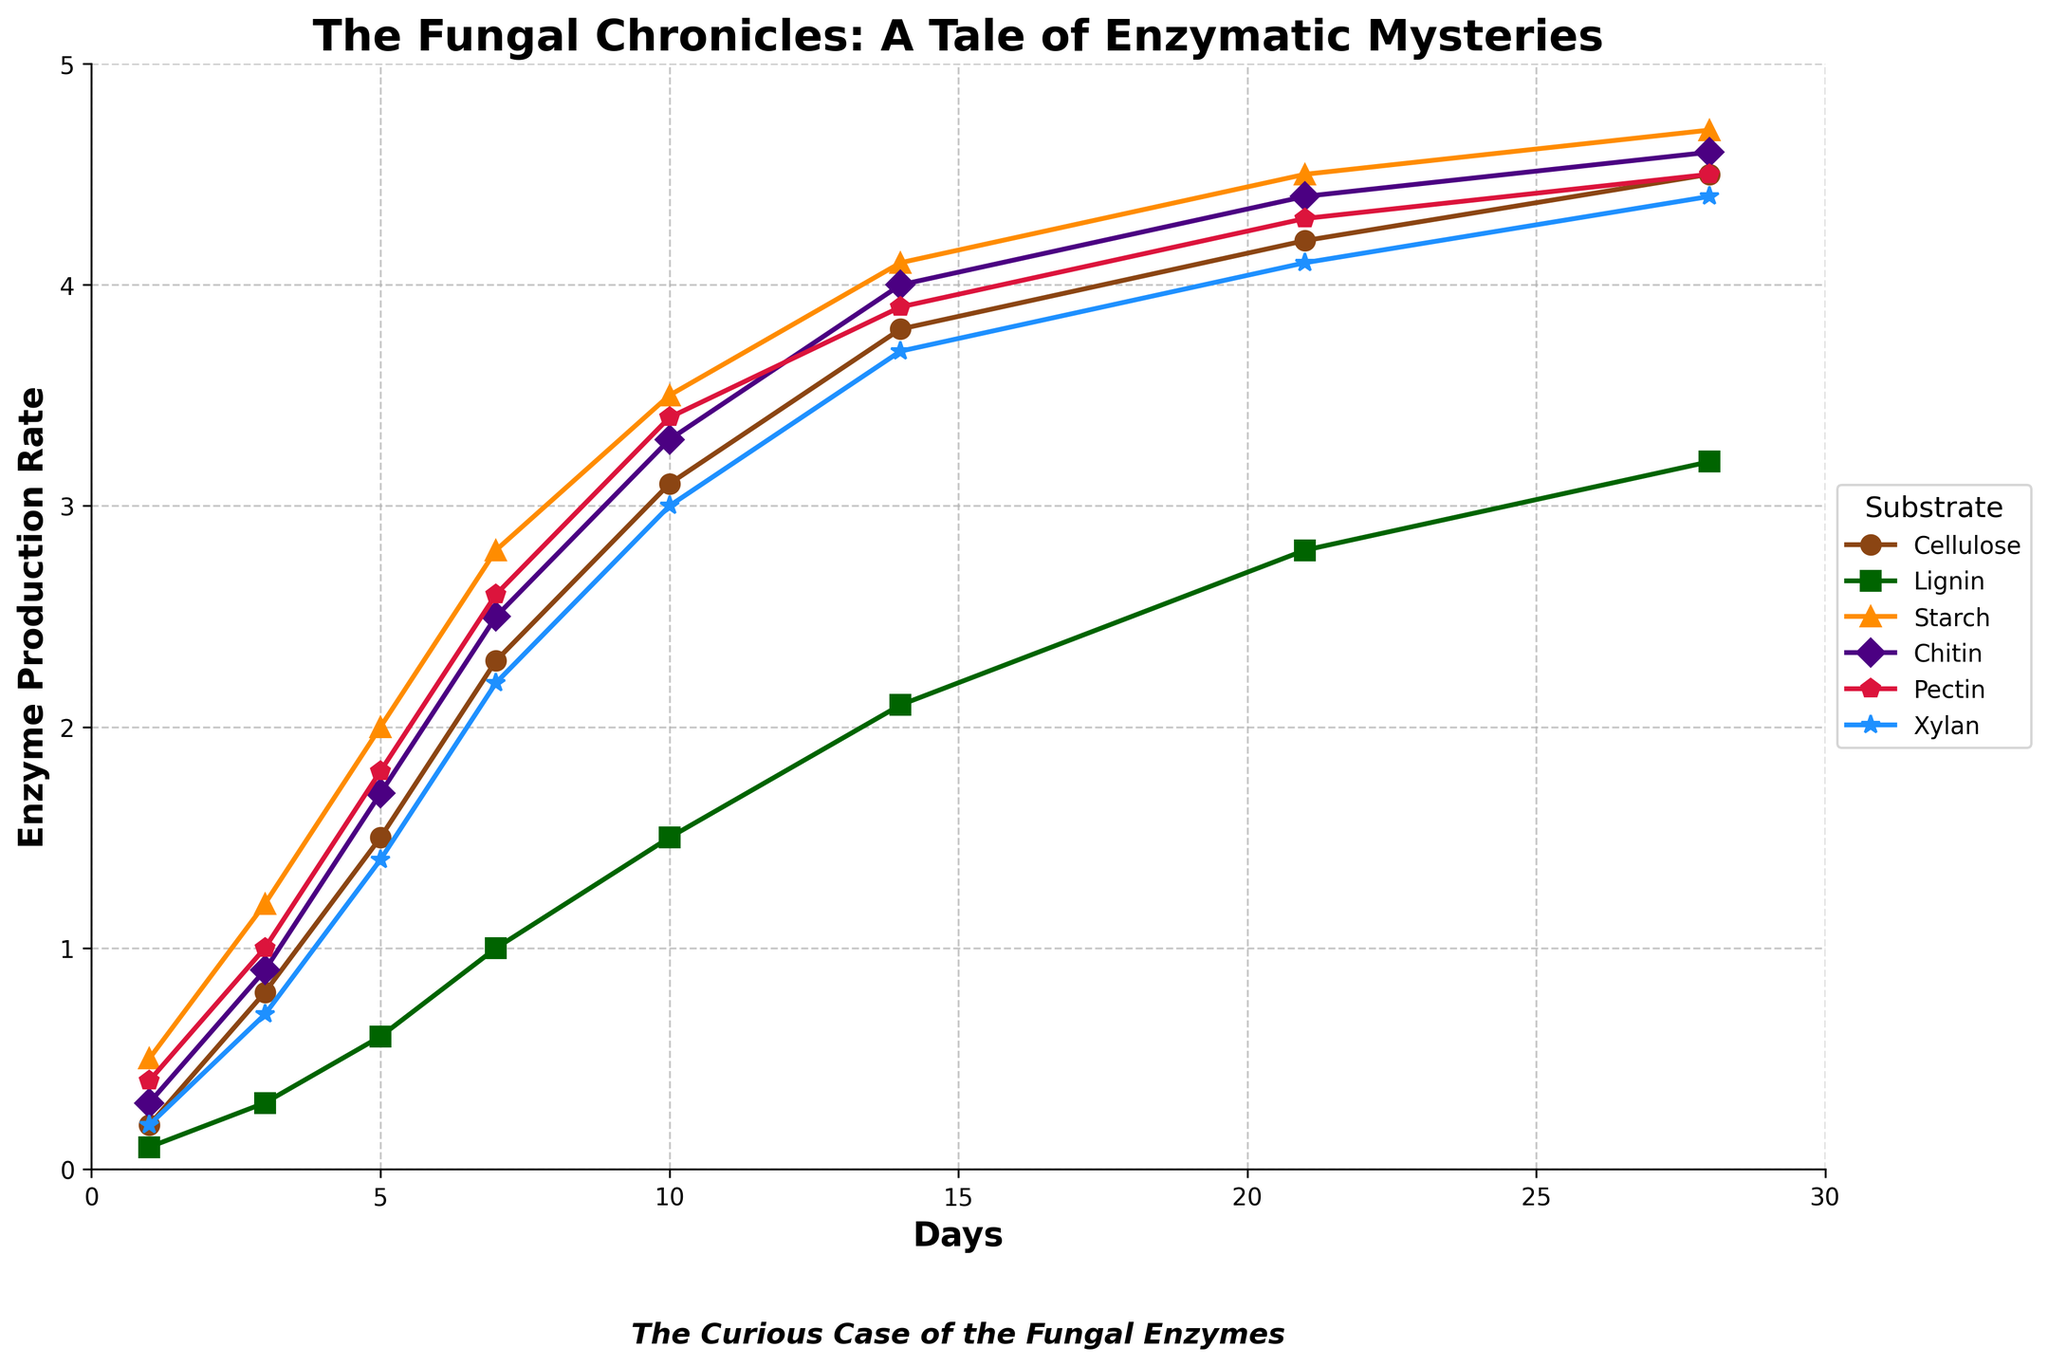Which substrate shows the highest enzyme production rate on Day 28? On Day 28, Starch has the highest enzyme production rate as its corresponding data point reaches the highest point on the y-axis among all substrates.
Answer: Starch By how much does the enzyme production rate for Chitin increase from Day 1 to Day 14? On Day 1, Chitin's production rate is 0.3, and on Day 14, it is 4.0. The increase is 4.0 - 0.3 = 3.7.
Answer: 3.7 Which substrates reach an enzyme production rate of 4.5 by Day 28? By looking at the data points on Day 28, Cellulose, Pectin, and Starch all touch or surpass the 4.5 mark, making them the substrates that reach this rate.
Answer: Cellulose, Pectin, Starch Which substrate has the slowest increase in enzyme production rate in the first 7 days? By comparing all substrates, Lignin has the smallest increase within the first 7 days, moving from 0.1 to 1.0, which is an increase of 0.9.
Answer: Lignin On what day does the enzyme production rate for Xylan surpass 3.0? Xylan's enzyme production rate surpasses 3.0 on Day 10 as indicated by the corresponding data point being above 3.0 on that day.
Answer: Day 10 Compare the enzyme production rates between Cellulose and Chitin on Day 21. Which one is higher and by how much? On Day 21, the enzyme production rate for Cellulose is 4.2, while for Chitin, it is 4.4. Chitin's rate is higher by 4.4 - 4.2 = 0.2.
Answer: Chitin, 0.2 Calculate the average enzyme production rate for Lignin over the entire period. The average is calculated by summing Lignin's rates over all days and dividing by the number of days: (0.1 + 0.3 + 0.6 + 1.0 + 1.5 + 2.1 + 2.8 + 3.2) / 8 = 11.6 / 8 = 1.45.
Answer: 1.45 Which substrate shows a consistent increase in enzyme production rate without any decrease over the observed time period? By observing each curve, all substrates show a consistent upward trend without any dips, thus all exhibit a continuous increase.
Answer: All substrates 